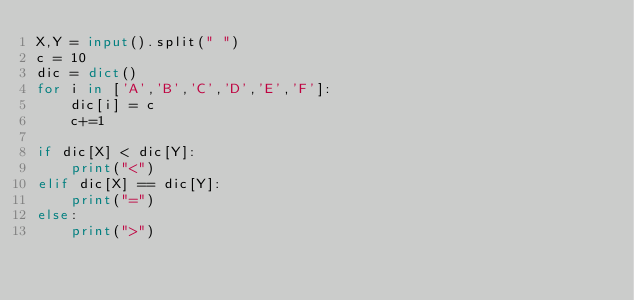<code> <loc_0><loc_0><loc_500><loc_500><_Python_>X,Y = input().split(" ")
c = 10
dic = dict()
for i in ['A','B','C','D','E','F']:
    dic[i] = c
    c+=1

if dic[X] < dic[Y]:
    print("<")
elif dic[X] == dic[Y]:
    print("=")
else:
    print(">")</code> 